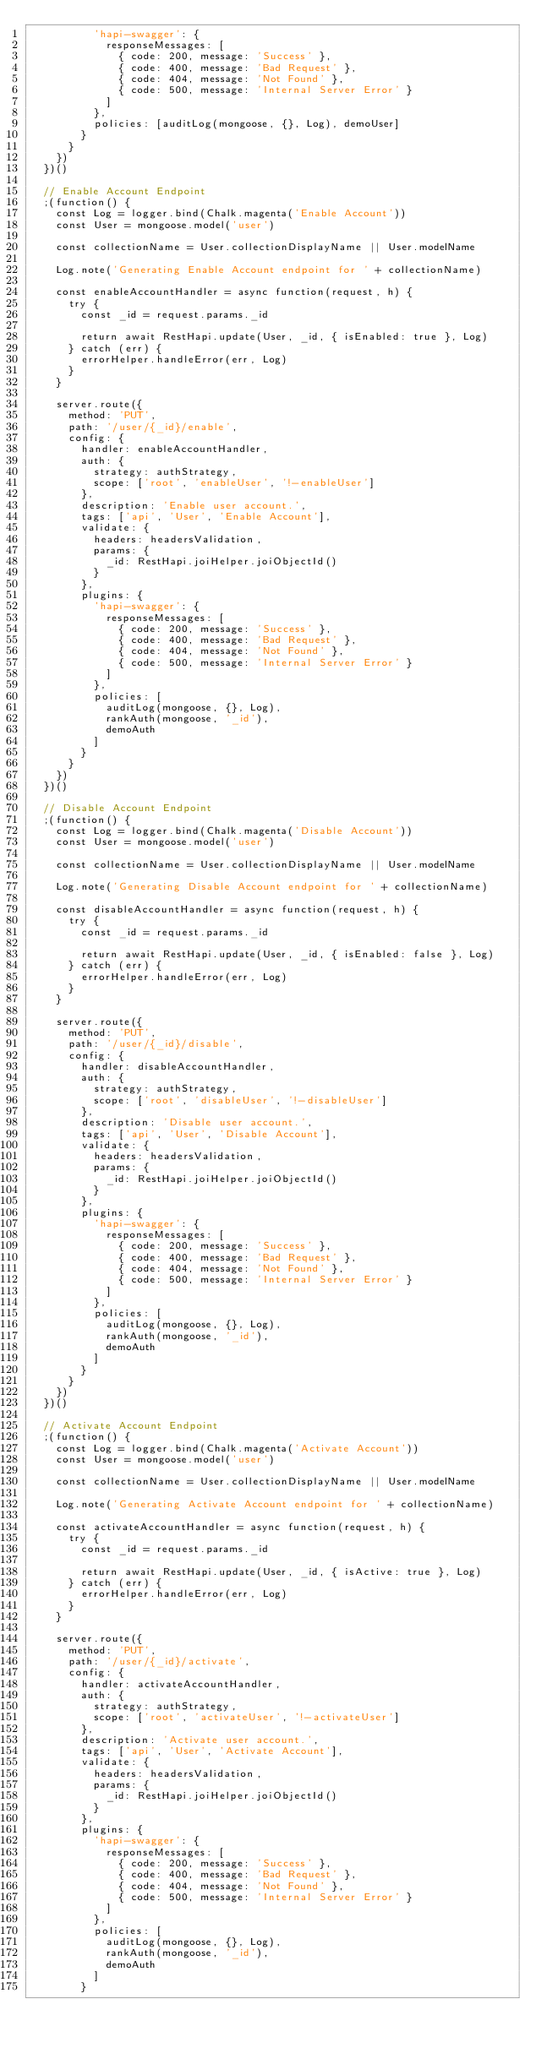<code> <loc_0><loc_0><loc_500><loc_500><_JavaScript_>          'hapi-swagger': {
            responseMessages: [
              { code: 200, message: 'Success' },
              { code: 400, message: 'Bad Request' },
              { code: 404, message: 'Not Found' },
              { code: 500, message: 'Internal Server Error' }
            ]
          },
          policies: [auditLog(mongoose, {}, Log), demoUser]
        }
      }
    })
  })()

  // Enable Account Endpoint
  ;(function() {
    const Log = logger.bind(Chalk.magenta('Enable Account'))
    const User = mongoose.model('user')

    const collectionName = User.collectionDisplayName || User.modelName

    Log.note('Generating Enable Account endpoint for ' + collectionName)

    const enableAccountHandler = async function(request, h) {
      try {
        const _id = request.params._id

        return await RestHapi.update(User, _id, { isEnabled: true }, Log)
      } catch (err) {
        errorHelper.handleError(err, Log)
      }
    }

    server.route({
      method: 'PUT',
      path: '/user/{_id}/enable',
      config: {
        handler: enableAccountHandler,
        auth: {
          strategy: authStrategy,
          scope: ['root', 'enableUser', '!-enableUser']
        },
        description: 'Enable user account.',
        tags: ['api', 'User', 'Enable Account'],
        validate: {
          headers: headersValidation,
          params: {
            _id: RestHapi.joiHelper.joiObjectId()
          }
        },
        plugins: {
          'hapi-swagger': {
            responseMessages: [
              { code: 200, message: 'Success' },
              { code: 400, message: 'Bad Request' },
              { code: 404, message: 'Not Found' },
              { code: 500, message: 'Internal Server Error' }
            ]
          },
          policies: [
            auditLog(mongoose, {}, Log),
            rankAuth(mongoose, '_id'),
            demoAuth
          ]
        }
      }
    })
  })()

  // Disable Account Endpoint
  ;(function() {
    const Log = logger.bind(Chalk.magenta('Disable Account'))
    const User = mongoose.model('user')

    const collectionName = User.collectionDisplayName || User.modelName

    Log.note('Generating Disable Account endpoint for ' + collectionName)

    const disableAccountHandler = async function(request, h) {
      try {
        const _id = request.params._id

        return await RestHapi.update(User, _id, { isEnabled: false }, Log)
      } catch (err) {
        errorHelper.handleError(err, Log)
      }
    }

    server.route({
      method: 'PUT',
      path: '/user/{_id}/disable',
      config: {
        handler: disableAccountHandler,
        auth: {
          strategy: authStrategy,
          scope: ['root', 'disableUser', '!-disableUser']
        },
        description: 'Disable user account.',
        tags: ['api', 'User', 'Disable Account'],
        validate: {
          headers: headersValidation,
          params: {
            _id: RestHapi.joiHelper.joiObjectId()
          }
        },
        plugins: {
          'hapi-swagger': {
            responseMessages: [
              { code: 200, message: 'Success' },
              { code: 400, message: 'Bad Request' },
              { code: 404, message: 'Not Found' },
              { code: 500, message: 'Internal Server Error' }
            ]
          },
          policies: [
            auditLog(mongoose, {}, Log),
            rankAuth(mongoose, '_id'),
            demoAuth
          ]
        }
      }
    })
  })()

  // Activate Account Endpoint
  ;(function() {
    const Log = logger.bind(Chalk.magenta('Activate Account'))
    const User = mongoose.model('user')

    const collectionName = User.collectionDisplayName || User.modelName

    Log.note('Generating Activate Account endpoint for ' + collectionName)

    const activateAccountHandler = async function(request, h) {
      try {
        const _id = request.params._id

        return await RestHapi.update(User, _id, { isActive: true }, Log)
      } catch (err) {
        errorHelper.handleError(err, Log)
      }
    }

    server.route({
      method: 'PUT',
      path: '/user/{_id}/activate',
      config: {
        handler: activateAccountHandler,
        auth: {
          strategy: authStrategy,
          scope: ['root', 'activateUser', '!-activateUser']
        },
        description: 'Activate user account.',
        tags: ['api', 'User', 'Activate Account'],
        validate: {
          headers: headersValidation,
          params: {
            _id: RestHapi.joiHelper.joiObjectId()
          }
        },
        plugins: {
          'hapi-swagger': {
            responseMessages: [
              { code: 200, message: 'Success' },
              { code: 400, message: 'Bad Request' },
              { code: 404, message: 'Not Found' },
              { code: 500, message: 'Internal Server Error' }
            ]
          },
          policies: [
            auditLog(mongoose, {}, Log),
            rankAuth(mongoose, '_id'),
            demoAuth
          ]
        }</code> 